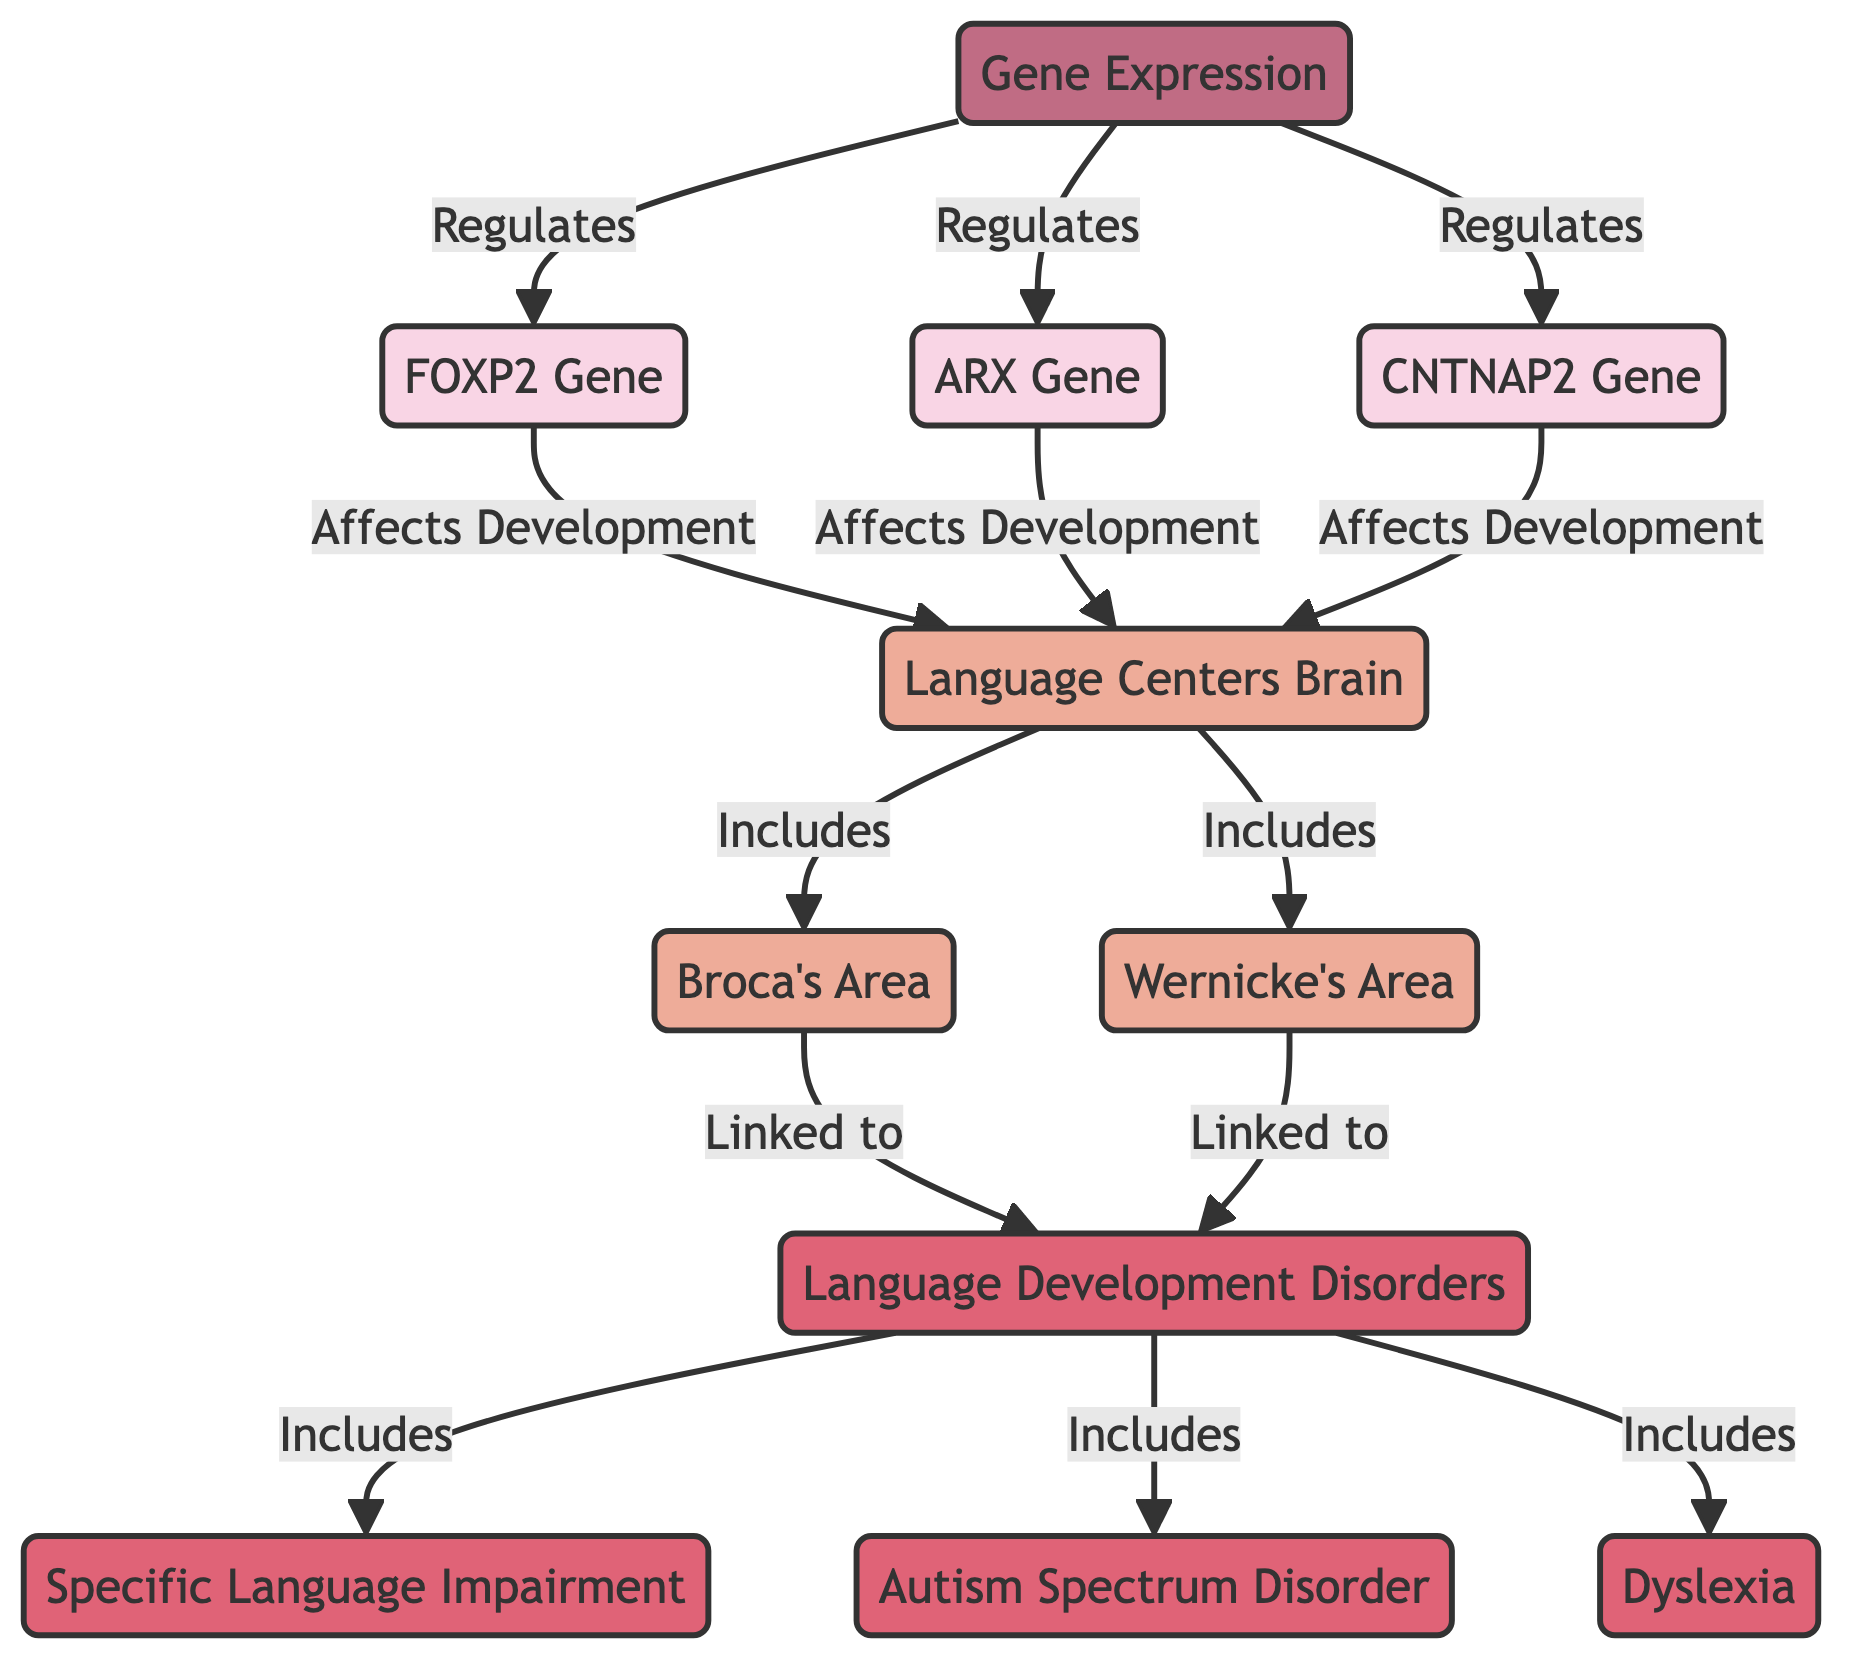What are the genes regulated by gene expression? According to the diagram, gene expression regulates three specific genes: FOXP2, ARX, and CNTNAP2. These connections are indicated by arrows leading from the "Gene Expression" node to each of the gene nodes.
Answer: FOXP2, ARX, CNTNAP2 Which brain areas are included in the language centers? The diagram states that the language centers include two brain areas: Broca's Area and Wernicke's Area. This is shown by the arrow from the "Language Centers Brain" node leading to both brain area nodes.
Answer: Broca's Area, Wernicke's Area How many language disorders are depicted in the diagram? The diagram shows three specific language disorders linked to the language development disorders node: Specific Language Impairment (SLI), Autism Spectrum Disorder (ASD), and Dyslexia. This can be counted by observing the connections to the "Language Development Disorders" node.
Answer: 3 Which gene affects the development of language centers? The diagram shows that all three genes—FOXP2, ARX, and CNTNAP2—affect the development of language centers, as each has an arrow pointing from the gene nodes to the "Language Centers Brain" node indicating their influence.
Answer: FOXP2, ARX, CNTNAP2 What is the relationship between Broca's Area and language disorders? According to the diagram, Broca's Area is linked to language disorders. The connection is illustrated by an arrow pointing from the "Broca's Area" node to the "Language Development Disorders" node, indicating that issues in Broca's Area can lead to such disorders.
Answer: Linked to language disorders 